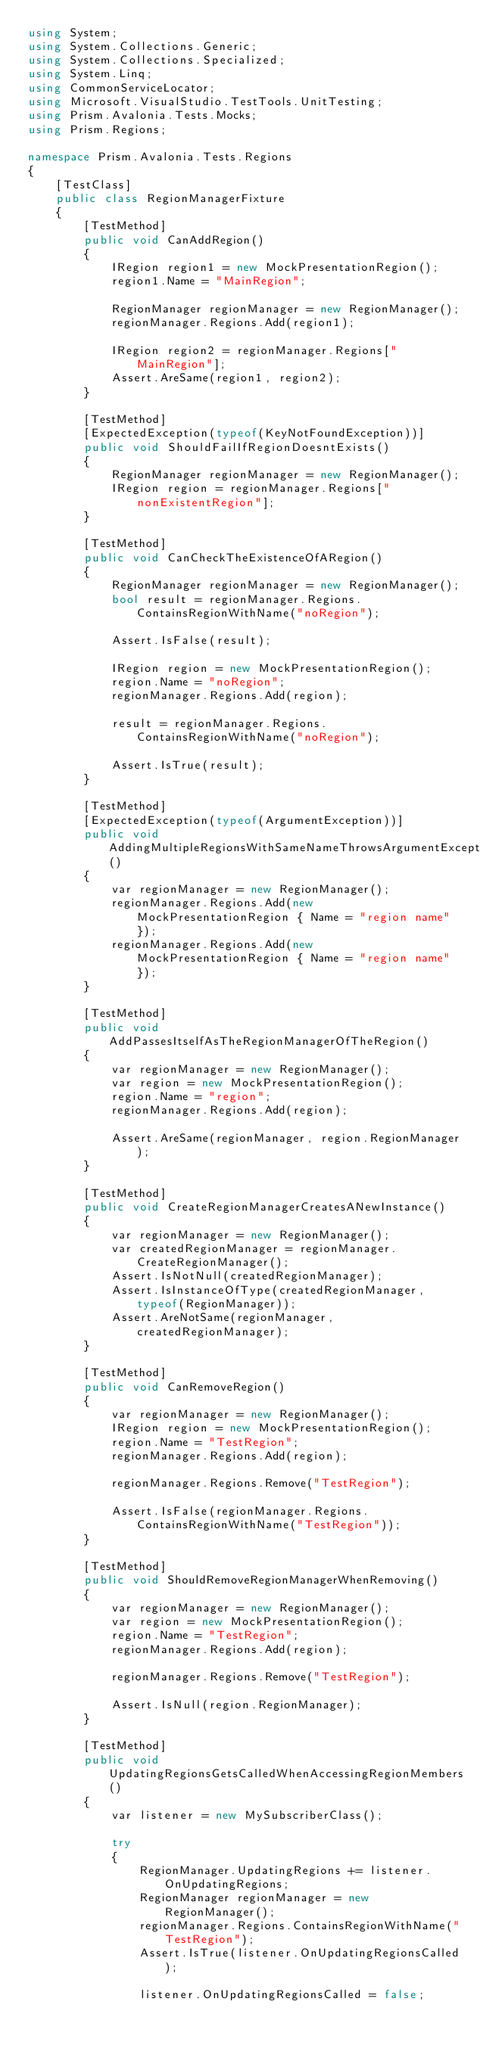<code> <loc_0><loc_0><loc_500><loc_500><_C#_>using System;
using System.Collections.Generic;
using System.Collections.Specialized;
using System.Linq;
using CommonServiceLocator;
using Microsoft.VisualStudio.TestTools.UnitTesting;
using Prism.Avalonia.Tests.Mocks;
using Prism.Regions;

namespace Prism.Avalonia.Tests.Regions
{
    [TestClass]
    public class RegionManagerFixture
    {
        [TestMethod]
        public void CanAddRegion()
        {
            IRegion region1 = new MockPresentationRegion();
            region1.Name = "MainRegion";

            RegionManager regionManager = new RegionManager();
            regionManager.Regions.Add(region1);

            IRegion region2 = regionManager.Regions["MainRegion"];
            Assert.AreSame(region1, region2);
        }

        [TestMethod]
        [ExpectedException(typeof(KeyNotFoundException))]
        public void ShouldFailIfRegionDoesntExists()
        {
            RegionManager regionManager = new RegionManager();
            IRegion region = regionManager.Regions["nonExistentRegion"];
        }

        [TestMethod]
        public void CanCheckTheExistenceOfARegion()
        {
            RegionManager regionManager = new RegionManager();
            bool result = regionManager.Regions.ContainsRegionWithName("noRegion");

            Assert.IsFalse(result);

            IRegion region = new MockPresentationRegion();
            region.Name = "noRegion";
            regionManager.Regions.Add(region);

            result = regionManager.Regions.ContainsRegionWithName("noRegion");

            Assert.IsTrue(result);
        }

        [TestMethod]
        [ExpectedException(typeof(ArgumentException))]
        public void AddingMultipleRegionsWithSameNameThrowsArgumentException()
        {
            var regionManager = new RegionManager();
            regionManager.Regions.Add(new MockPresentationRegion { Name = "region name" });
            regionManager.Regions.Add(new MockPresentationRegion { Name = "region name" });
        }

        [TestMethod]
        public void AddPassesItselfAsTheRegionManagerOfTheRegion()
        {
            var regionManager = new RegionManager();
            var region = new MockPresentationRegion();
            region.Name = "region";
            regionManager.Regions.Add(region);

            Assert.AreSame(regionManager, region.RegionManager);
        }

        [TestMethod]
        public void CreateRegionManagerCreatesANewInstance()
        {
            var regionManager = new RegionManager();
            var createdRegionManager = regionManager.CreateRegionManager();
            Assert.IsNotNull(createdRegionManager);
            Assert.IsInstanceOfType(createdRegionManager, typeof(RegionManager));
            Assert.AreNotSame(regionManager, createdRegionManager);
        }

        [TestMethod]
        public void CanRemoveRegion()
        {
            var regionManager = new RegionManager();
            IRegion region = new MockPresentationRegion();
            region.Name = "TestRegion";
            regionManager.Regions.Add(region);

            regionManager.Regions.Remove("TestRegion");

            Assert.IsFalse(regionManager.Regions.ContainsRegionWithName("TestRegion"));
        }

        [TestMethod]
        public void ShouldRemoveRegionManagerWhenRemoving()
        {
            var regionManager = new RegionManager();
            var region = new MockPresentationRegion();
            region.Name = "TestRegion";
            regionManager.Regions.Add(region);

            regionManager.Regions.Remove("TestRegion");

            Assert.IsNull(region.RegionManager);
        }

        [TestMethod]
        public void UpdatingRegionsGetsCalledWhenAccessingRegionMembers()
        {
            var listener = new MySubscriberClass();

            try
            {
                RegionManager.UpdatingRegions += listener.OnUpdatingRegions;
                RegionManager regionManager = new RegionManager();
                regionManager.Regions.ContainsRegionWithName("TestRegion");
                Assert.IsTrue(listener.OnUpdatingRegionsCalled);

                listener.OnUpdatingRegionsCalled = false;</code> 